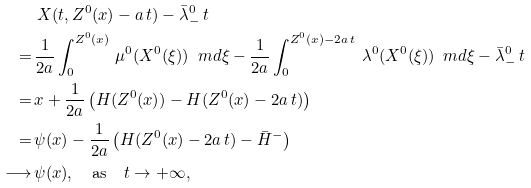Convert formula to latex. <formula><loc_0><loc_0><loc_500><loc_500>& \, X ( t , Z ^ { 0 } ( x ) - a \, t ) - \bar { \lambda } ^ { 0 } _ { - } \, t \\ = \, & \frac { 1 } { 2 a } \int _ { 0 } ^ { Z ^ { 0 } ( x ) } \, \mu ^ { 0 } ( X ^ { 0 } ( \xi ) ) \, \ m d \xi - \frac { 1 } { 2 a } \int _ { 0 } ^ { Z ^ { 0 } ( x ) - 2 a \, t } \, \lambda ^ { 0 } ( X ^ { 0 } ( \xi ) ) \, \ m d \xi - \bar { \lambda } ^ { 0 } _ { - } \, t \\ = \, & x + \frac { 1 } { 2 a } \left ( H ( Z ^ { 0 } ( x ) ) - H ( Z ^ { 0 } ( x ) - 2 a \, t ) \right ) \\ = \, & \psi ( x ) - \frac { 1 } { 2 a } \left ( H ( Z ^ { 0 } ( x ) - 2 a \, t ) - \bar { H } ^ { - } \right ) \\ \longrightarrow \, & \psi ( x ) , \quad \text {as} \quad t \rightarrow + \infty ,</formula> 